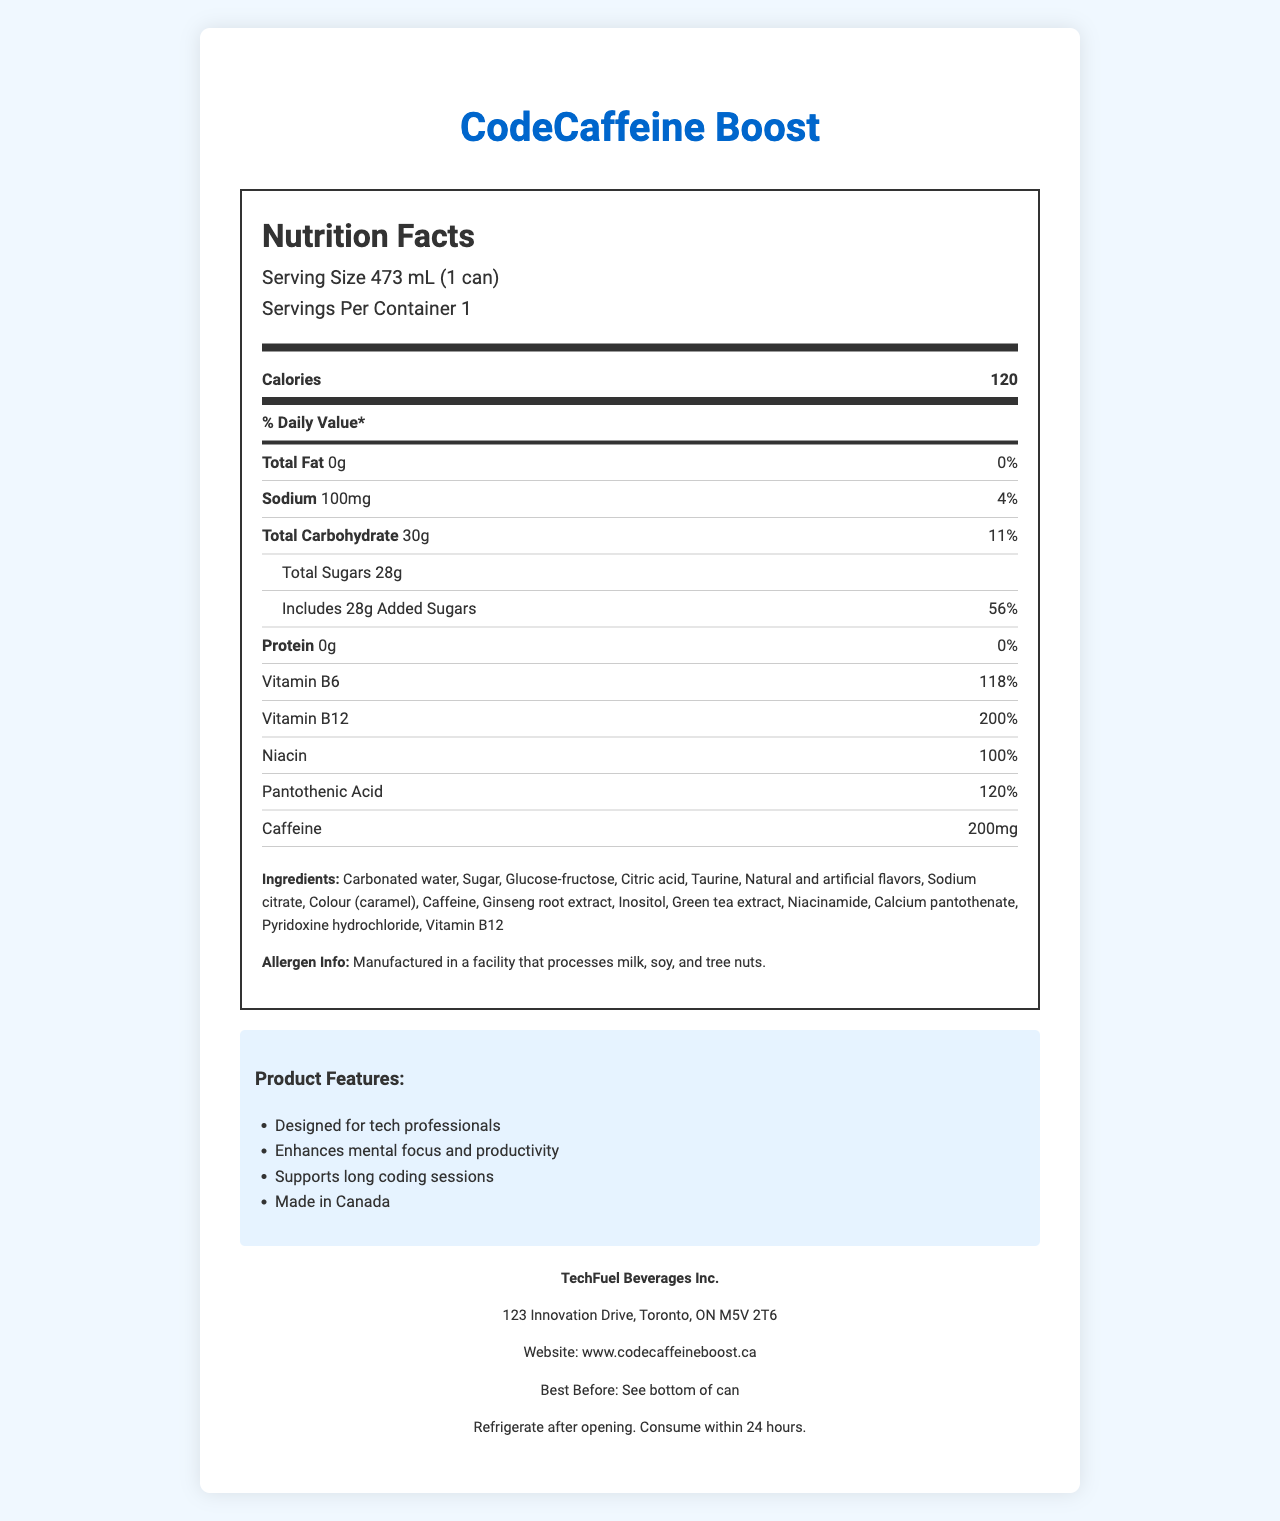What is the serving size for CodeCaffeine Boost? The serving size is listed at the top of the Nutrition Facts Label under the servings information as "Serving Size 473 mL (1 can)".
Answer: 473 mL (1 can) How many calories are in one serving of CodeCaffeine Boost? The calories per serving are listed in bold text under the "Calories" section.
Answer: 120 What percentage of the daily value does Vitamin B12 provide? The daily value percentage for Vitamin B12 is listed in the "Vitamin B12" row as 200%.
Answer: 200% What is the amount of caffeine included in CodeCaffeine Boost? The amount of caffeine is listed under its own row as "Caffeine 200mg".
Answer: 200mg Is there any fat in CodeCaffeine Boost? The total fat is listed as "Total Fat 0g" with a daily value of 0%, indicating there is no fat.
Answer: No, there is 0g of total fat What are the main marketing claims of CodeCaffeine Boost? Marketing claims are under the "Product Features" section.
Answer: Designed for tech professionals, Enhances mental focus and productivity, Supports long coding sessions, Made in Canada Which ingredient is listed first? A. Ginseng B. Green tea extract C. Carbonated water D. Sugar The first ingredient listed is "Carbonated water" under the "Ingredients" section.
Answer: C. Carbonated water How much sodium is in the CodeCaffeine Boost? A. 50mg B. 100mg C. 150mg D. 200mg The sodium content is listed under the "Sodium" row as "Sodium 100mg".
Answer: B. 100mg Is CodeCaffeine Boost manufactured in Canada? This is confirmed by the product claim "Made in Canada" listed under the marketing claims.
Answer: Yes Does CodeCaffeine Boost contain allergens? The allergen info states: "Manufactured in a facility that processes milk, soy, and tree nuts."
Answer: Yes Summarize the key nutritional information of CodeCaffeine Boost. The summary includes the essential nutritional facts and key ingredients relevant to the product.
Answer: CodeCaffeine Boost is an energy drink with 120 calories per 473 mL can. It contains 0g of fat, 100mg of sodium, 30g of carbohydrates, including 28g of added sugars, and 0g of protein. It is fortified with 118% of the daily value for Vitamin B6, 200% for Vitamin B12, 100% for Niacin, and 120% for Pantothenic Acid. It also includes 200mg of caffeine, 1000mg of taurine, 100mg of ginseng, and 50mg of green tea extract. What is the Canadian Nutrient File Number for CodeCaffeine Boost? This specific detail does not appear on the rendered document but is present in the dataset.
Answer: Cannot be determined What are the benefits marketed for CodeCaffeine Boost? The marketing claims state that it is designed specifically for tech professionals and provides benefits such as enhanced mental focus and productivity and support for long coding sessions.
Answer: Enhances mental focus and productivity, Supports long coding sessions, Made in Canada Does CodeCaffeine Boost provide any protein? The protein content is listed as "0g" with a daily value of "0%".
Answer: No What is the amount of added sugars in CodeCaffeine Boost? The added sugars are explicitly stated under the "Includes 28g Added Sugars" row.
Answer: 28g 